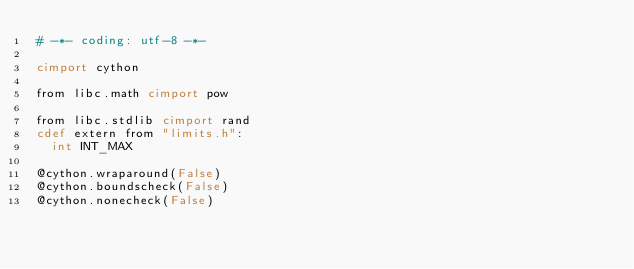<code> <loc_0><loc_0><loc_500><loc_500><_Cython_># -*- coding: utf-8 -*-

cimport cython

from libc.math cimport pow

from libc.stdlib cimport rand
cdef extern from "limits.h":
  int INT_MAX

@cython.wraparound(False)
@cython.boundscheck(False)
@cython.nonecheck(False)</code> 